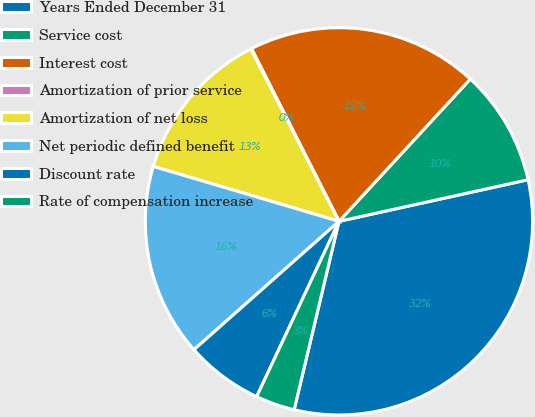Convert chart. <chart><loc_0><loc_0><loc_500><loc_500><pie_chart><fcel>Years Ended December 31<fcel>Service cost<fcel>Interest cost<fcel>Amortization of prior service<fcel>Amortization of net loss<fcel>Net periodic defined benefit<fcel>Discount rate<fcel>Rate of compensation increase<nl><fcel>32.16%<fcel>9.69%<fcel>19.32%<fcel>0.06%<fcel>12.9%<fcel>16.11%<fcel>6.48%<fcel>3.27%<nl></chart> 